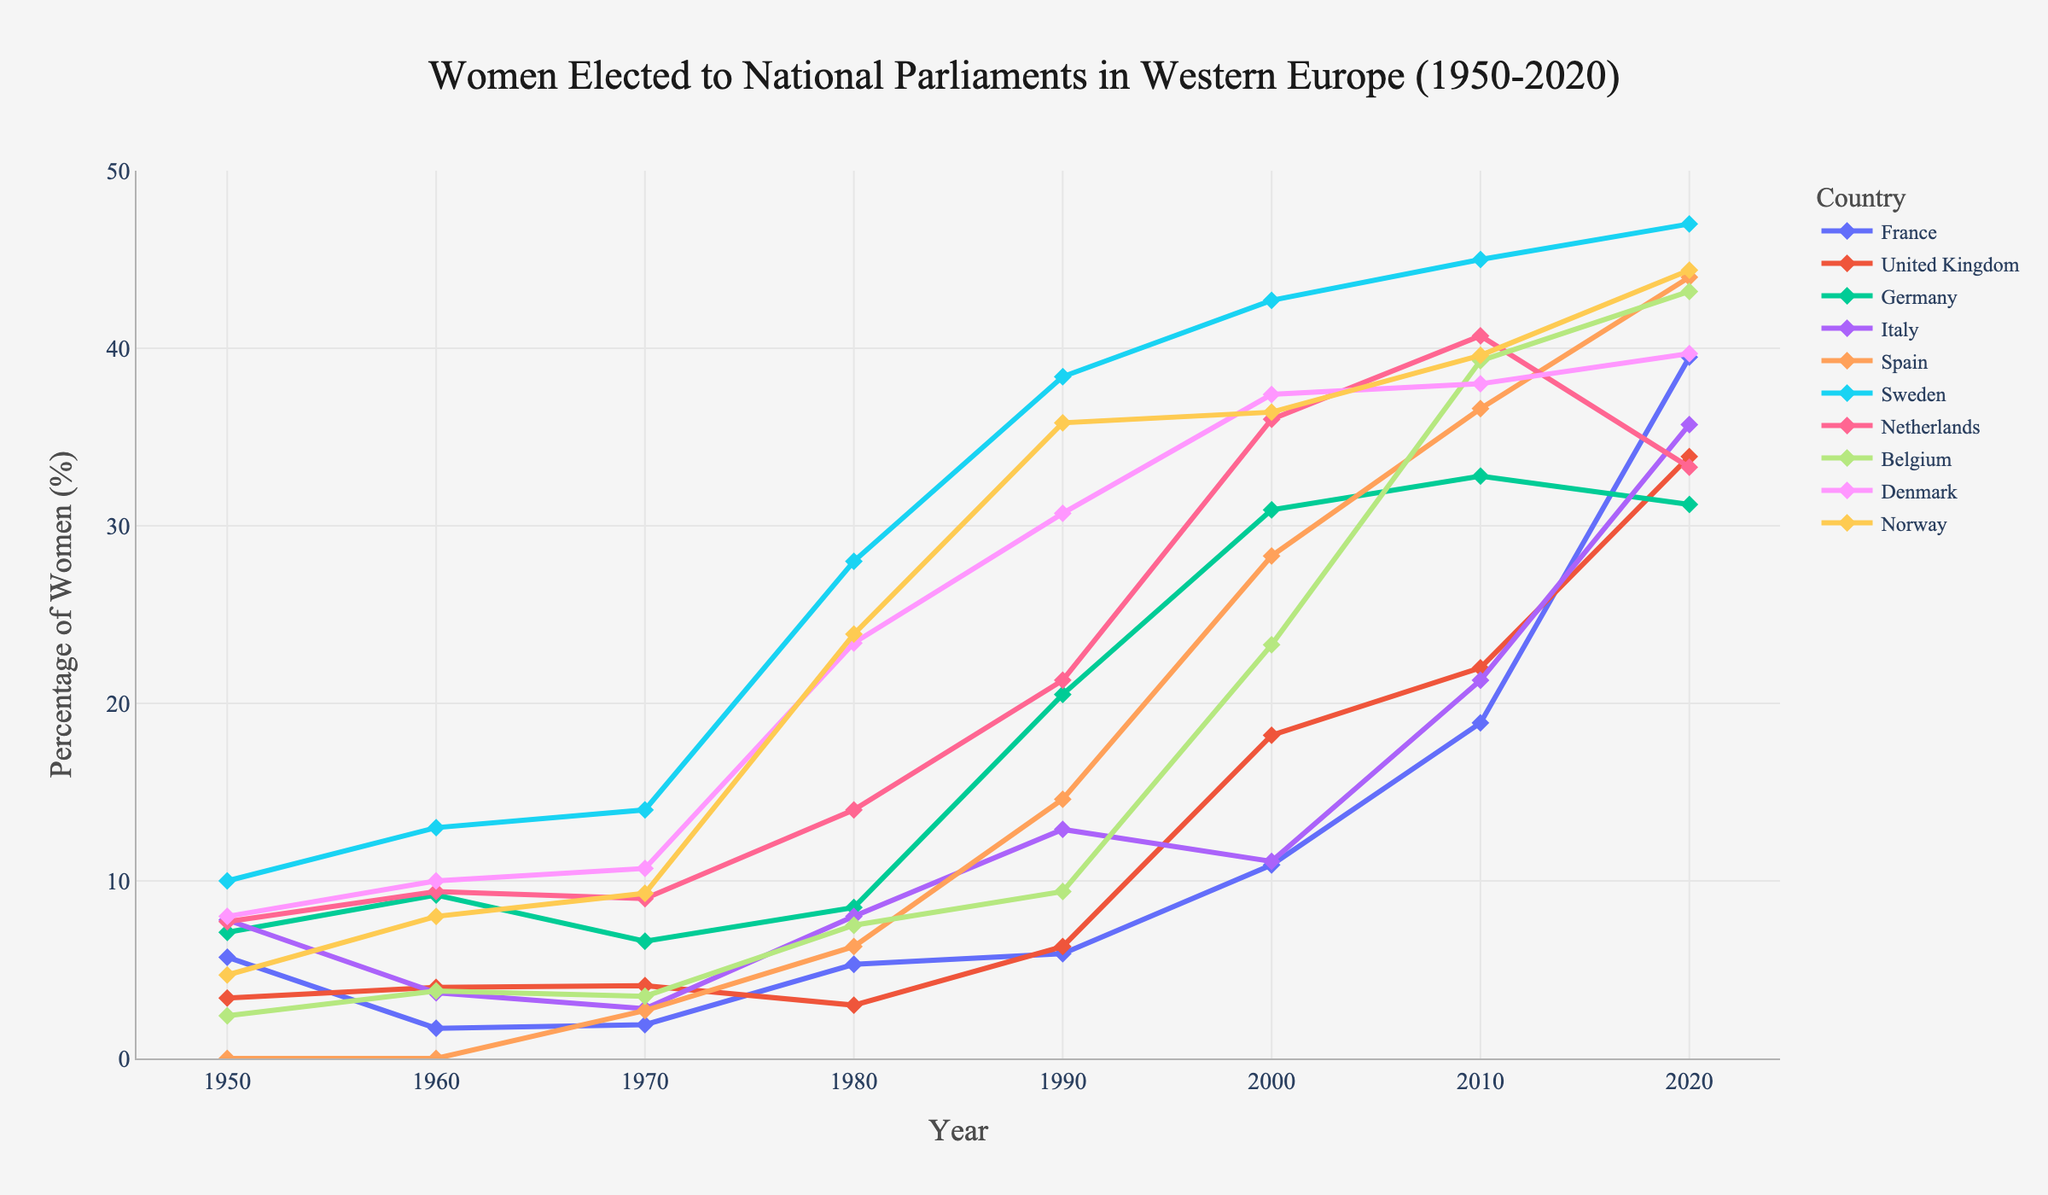What is the general trend in the percentage of women elected to national parliaments in Western Europe between 1950 and 2020? Observing the lines in the graph, all countries show an increasing trend over the years, indicating a rise in the percentage of women elected to national parliaments over this period.
Answer: Increasing Which country had the highest percentage of women in national parliaments in 2020? Looking at the end point of each line (2020), Sweden is at the highest point, indicating it had the highest percentage of women in national parliaments in 2020.
Answer: Sweden What is the range of percentage points for women elected in Germany from 1950 to 2020? The range is calculated by subtracting the lowest percentage in 1950 (7.1%) from the highest percentage in 2020 (32.8%).
Answer: 25.7 Which country had the lowest percentage of women in parliaments in 1950 and which country had the highest percentage in the same year? Observing the starting points of each country's line at 1950, France had the lowest percentage (5.7%) and Sweden had the highest percentage (10.0%).
Answer: France (lowest), Sweden (highest) Between which years did Denmark see the most significant increase in women's parliamentary representation? Examining the slope of Denmark's line, the steepest increase occurs between 1970 and 1980, where the percentage jumped from 10.7% to 23.4%.
Answer: 1970 to 1980 How does the change in the percentage of women elected in France from 2000 to 2020 compare with that in Spain during the same period? Calculating the changes: For France, it's 39.5% - 10.9% = 28.6% change. For Spain, it's 44.0% - 28.3% = 15.7% change. France had a greater increase compared to Spain.
Answer: France had a greater increase Which countries had over 40% women representation in national parliaments in 2020? Looking at the lines in 2020, the countries exceeding 40% are Sweden, Spain, Belgium, and Norway.
Answer: Sweden, Spain, Belgium, Norway What was the percentage change in women's representation in national parliaments in Italy from 1990 to 2010? Calculating the change: 2010 percentage (21.3%) - 1990 percentage (12.9%) = 8.4%.
Answer: 8.4% Which country shows the most stable or least fluctuating trend in the percentage of women elected to parliaments from 1950 to 2020? Observing the smoothness of the lines, Norway's trend appears to be fairly stable without large fluctuations.
Answer: Norway In which decade did Belgium see the start of a significant rise in the number of women elected to national parliaments? Looking at Belgium's line, a notable increase begins in the 1990s.
Answer: 1990s 